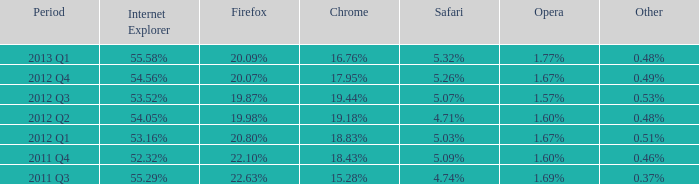What safari has 2012 q4 as the period? 5.26%. Would you be able to parse every entry in this table? {'header': ['Period', 'Internet Explorer', 'Firefox', 'Chrome', 'Safari', 'Opera', 'Other'], 'rows': [['2013 Q1', '55.58%', '20.09%', '16.76%', '5.32%', '1.77%', '0.48%'], ['2012 Q4', '54.56%', '20.07%', '17.95%', '5.26%', '1.67%', '0.49%'], ['2012 Q3', '53.52%', '19.87%', '19.44%', '5.07%', '1.57%', '0.53%'], ['2012 Q2', '54.05%', '19.98%', '19.18%', '4.71%', '1.60%', '0.48%'], ['2012 Q1', '53.16%', '20.80%', '18.83%', '5.03%', '1.67%', '0.51%'], ['2011 Q4', '52.32%', '22.10%', '18.43%', '5.09%', '1.60%', '0.46%'], ['2011 Q3', '55.29%', '22.63%', '15.28%', '4.74%', '1.69%', '0.37%']]} 